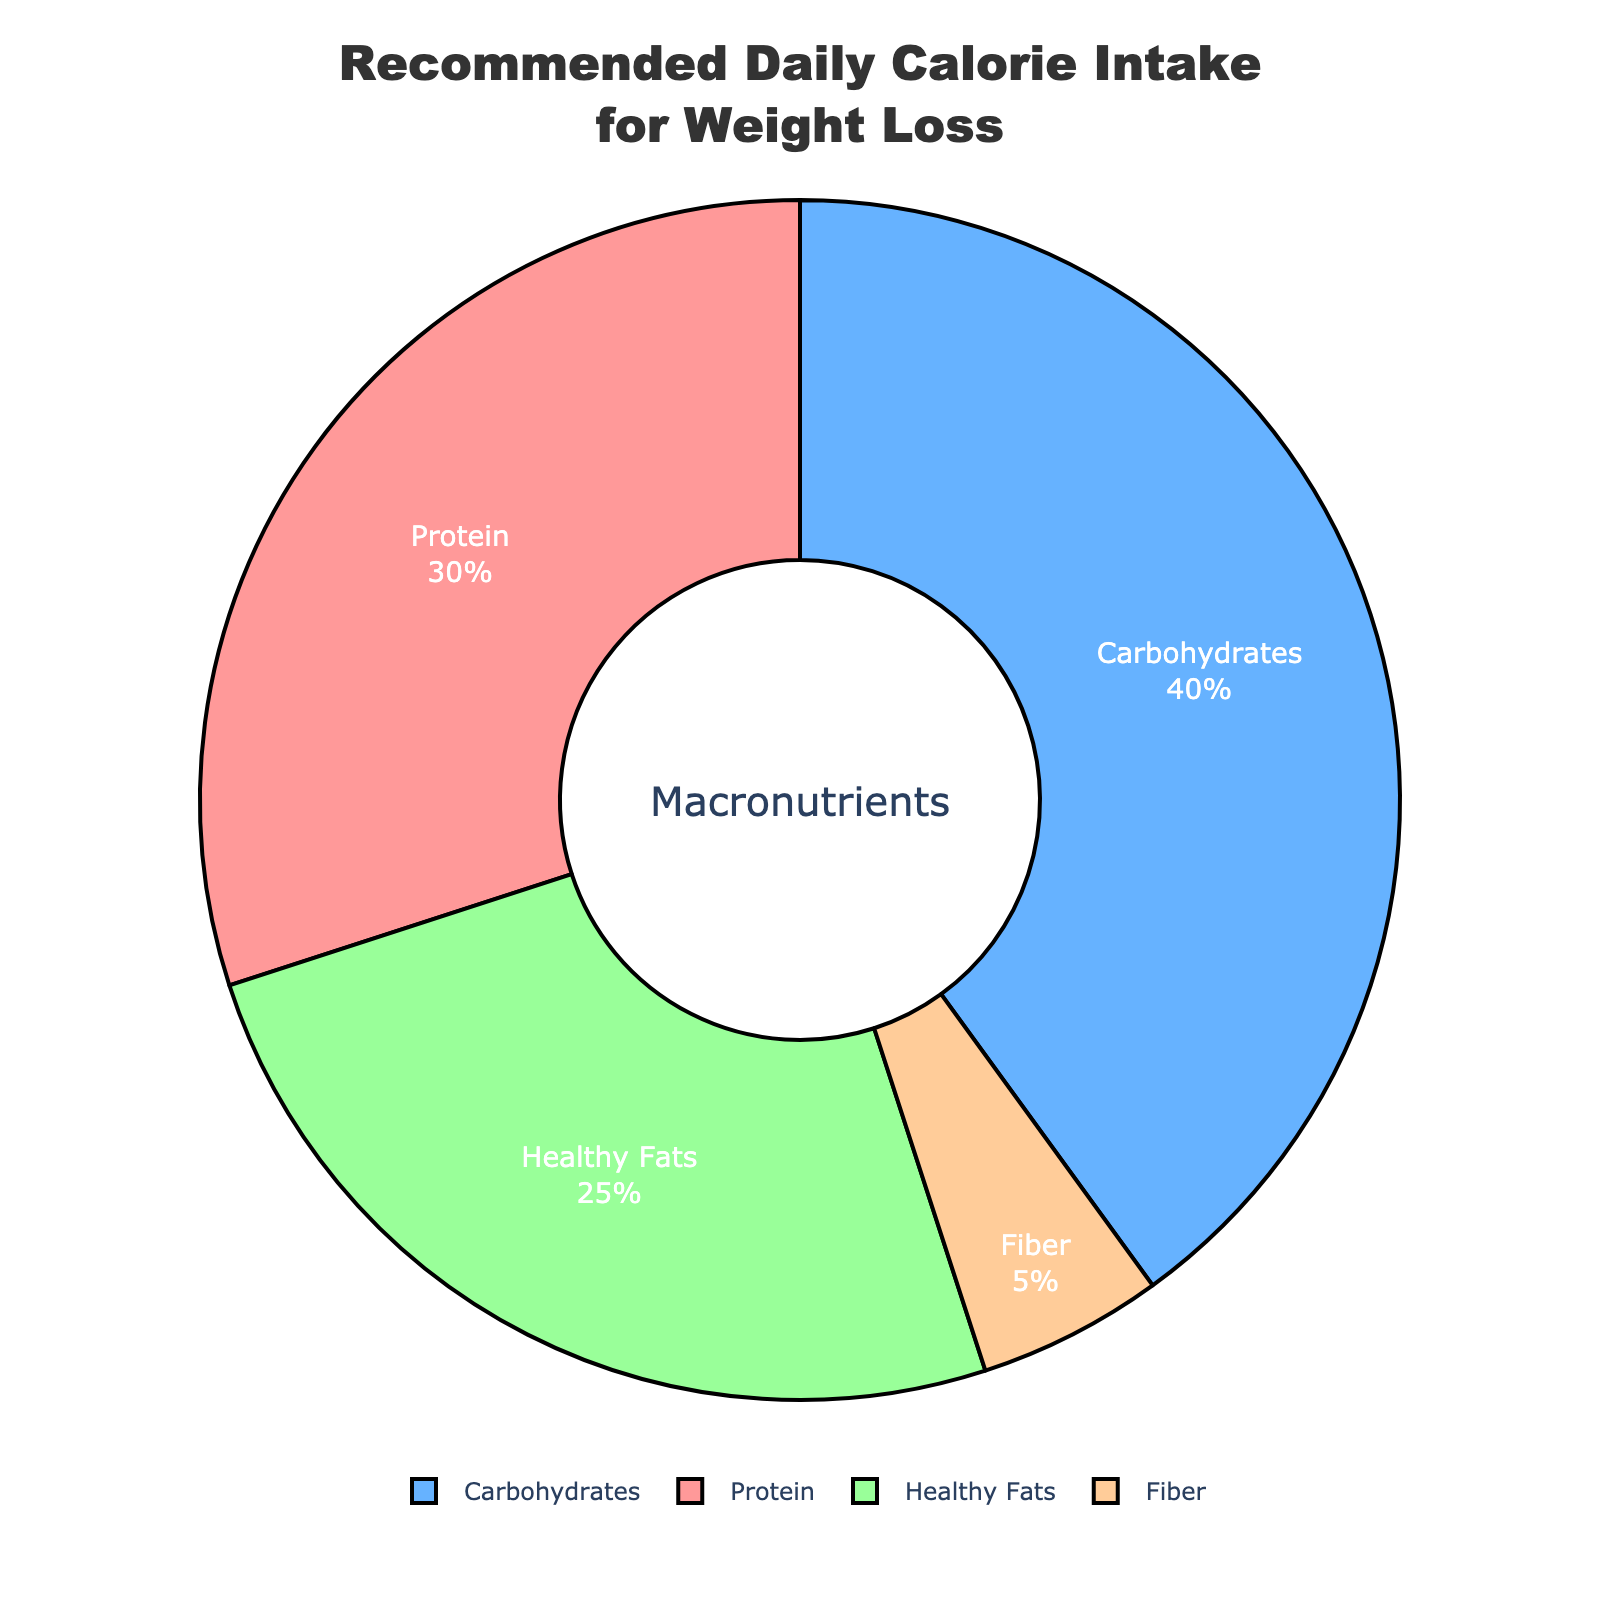What percentage of the recommended daily calorie intake should come from protein? When looking at the pie chart, the section labeled "Protein" shows the percentage of the recommended daily calorie intake for weight loss that should come from protein. This slice of the pie chart is labeled as 30%.
Answer: 30% How do the combined contributions of healthy fats and fiber compare to that of carbohydrates? First, identify the percentage contributions of healthy fats and fiber, which are 25% and 5% respectively. Summing them gives 25% + 5% = 30%. The chart shows that carbohydrates contribute 40%. Comparing the two totals, 40% (carbohydrates) is larger than 30% (healthy fats and fiber combined).
Answer: Carbohydrates (40%) are greater What is the total percentage of calories recommended from protein and carbohydrates combined? Identify the percentage for protein (30%) and carbohydrates (40%) from the pie chart. Add these values together: 30% + 40% = 70%.
Answer: 70% Which macronutrient has the smallest percentage of the recommended daily calorie intake, and what is this percentage? Looking at the pie chart, "Fiber" is the smallest segment, showing a percentage of 5%.
Answer: Fiber, 5% Are the calories from protein higher or lower than those from healthy fats? Referring to the pie chart, the "Protein" segment shows 30%, and the "Healthy Fats" segment shows 25%. Since 30% is higher than 25%, the calories from protein are higher than those from healthy fats.
Answer: Higher What is the visual color used to represent carbohydrates in the chart? In the pie chart, the section representing carbohydrates appears in blue.
Answer: Blue If you were to combine the contributions from fiber and protein, would this combination exceed the contribution from carbohydrates? First, add the percentages for fiber and protein: 5% (fiber) + 30% (protein) = 35%. The carbohydrates contribute 40%. Since 35% is less than 40%, the combination does not exceed the carbohydrates.
Answer: No, it does not exceed If fiber’s percentage was doubled, what would be its new contribution to the pie chart, and how would it affect the overall percentages? Doubling the current fiber percentage of 5% results in 10%. Keeping the total always as 100%, the new distribution becomes: Protein 30%, Carbohydrates 40%, Healthy Fats 25%, and Fiber 10%. Sum these to verify: 30% + 40% + 25% + 10% = 105%. Since the total exceeds 100%, recalculations should adjust other macronutrients accordingly to accommodate this increase within a 100% sum. The new fiber percentage remains 10% post doubling.
Answer: Fiber new 10%, Recalculation needed to adjust others within 100% Which macronutrient contributes a quarter of the daily caloric intake? Reviewing the pie chart, the "Healthy Fats" section accounts for 25% of the recommended daily caloric intake.
Answer: Healthy Fats If the total recommended daily calories are set to 2000 kcal, how many calories should come from protein? Knowing protein represents 30% from the pie chart, and applying this to 2000 kcal: 30% of 2000 kcal is calculated as (30/100) * 2000 = 600 kcal.
Answer: 600 kcal 